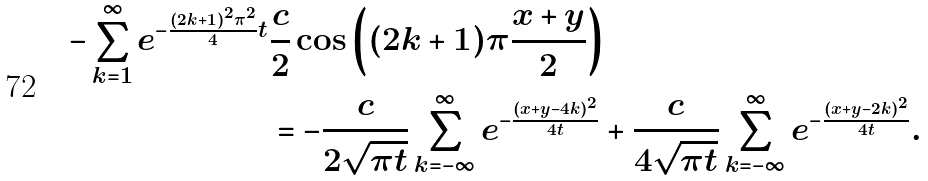Convert formula to latex. <formula><loc_0><loc_0><loc_500><loc_500>- \sum _ { k = 1 } ^ { \infty } e ^ { - \frac { ( 2 k + 1 ) ^ { 2 } \pi ^ { 2 } } { 4 } t } & \frac { c } { 2 } \cos \left ( ( 2 k + 1 ) \pi \frac { x + y } { 2 } \right ) \\ & = - \frac { c } { 2 \sqrt { \pi t } } \sum _ { k = - \infty } ^ { \infty } e ^ { - \frac { ( x + y - 4 k ) ^ { 2 } } { 4 t } } + \frac { c } { 4 \sqrt { \pi t } } \sum _ { k = - \infty } ^ { \infty } e ^ { - \frac { ( x + y - 2 k ) ^ { 2 } } { 4 t } } .</formula> 